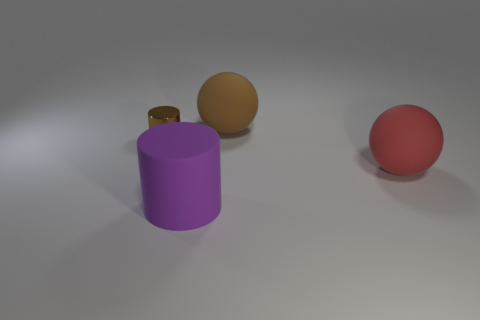Add 3 tiny brown shiny cylinders. How many objects exist? 7 Add 2 tiny gray rubber cylinders. How many tiny gray rubber cylinders exist? 2 Subtract 0 blue balls. How many objects are left? 4 Subtract all yellow rubber spheres. Subtract all spheres. How many objects are left? 2 Add 1 big brown spheres. How many big brown spheres are left? 2 